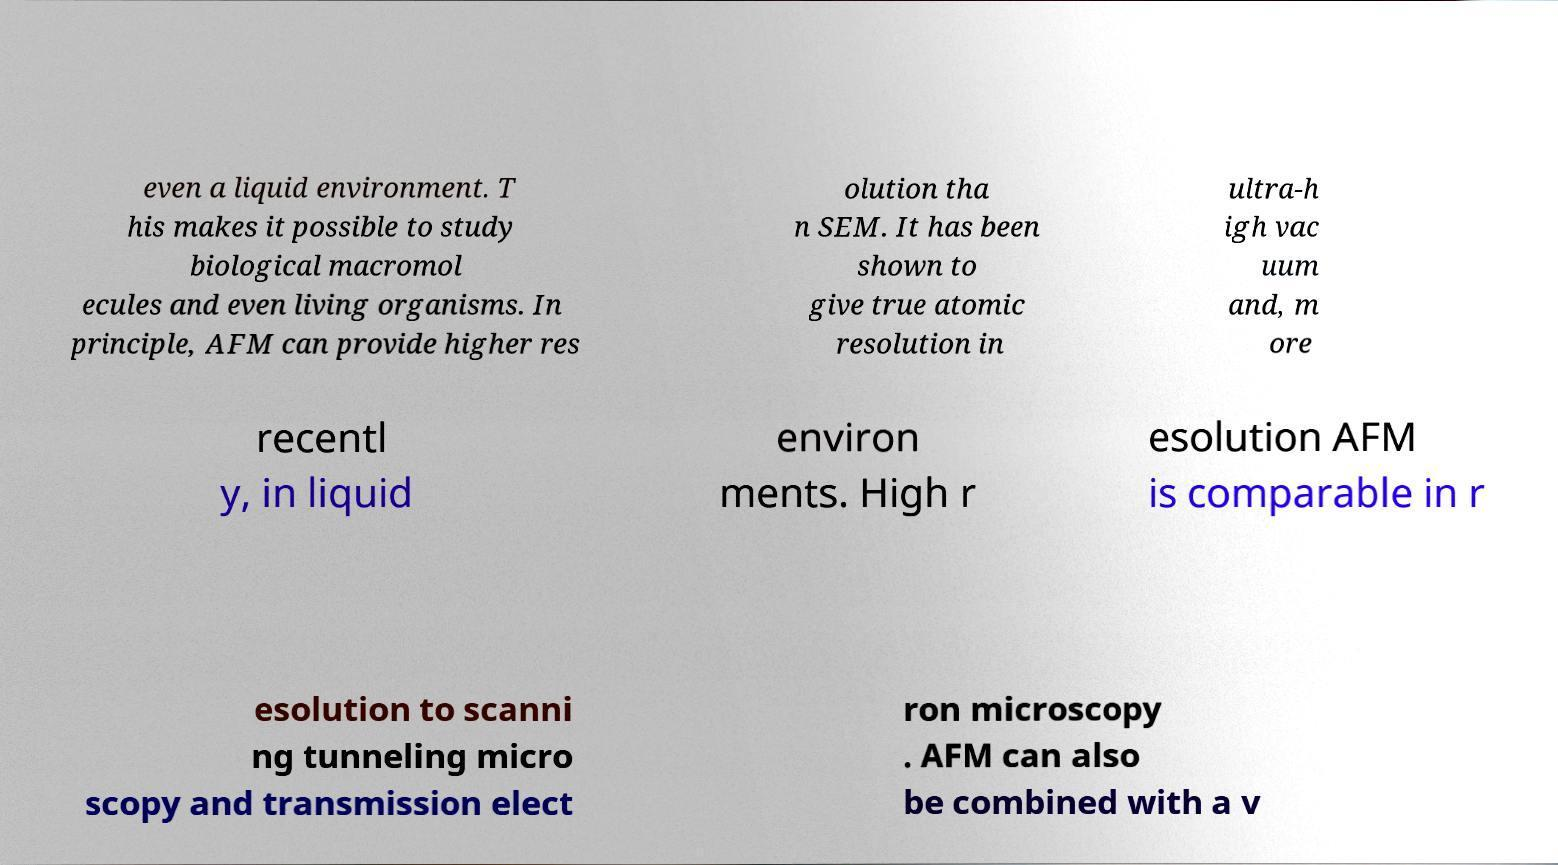Could you extract and type out the text from this image? even a liquid environment. T his makes it possible to study biological macromol ecules and even living organisms. In principle, AFM can provide higher res olution tha n SEM. It has been shown to give true atomic resolution in ultra-h igh vac uum and, m ore recentl y, in liquid environ ments. High r esolution AFM is comparable in r esolution to scanni ng tunneling micro scopy and transmission elect ron microscopy . AFM can also be combined with a v 